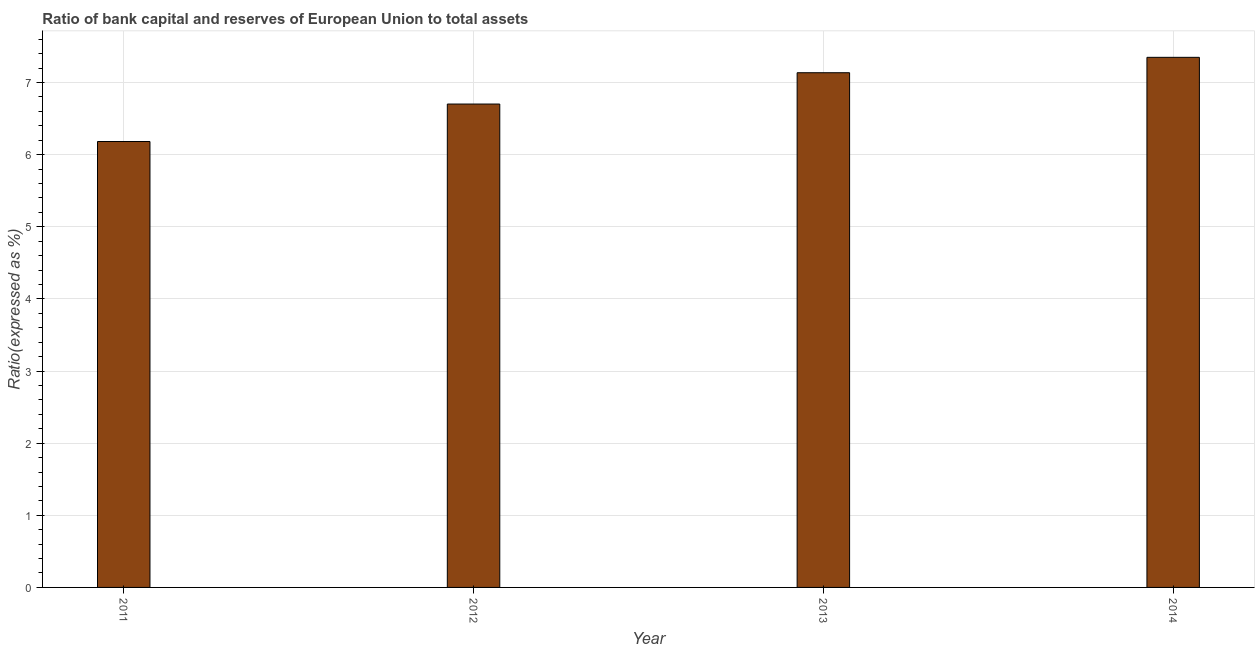Does the graph contain any zero values?
Provide a short and direct response. No. What is the title of the graph?
Your answer should be very brief. Ratio of bank capital and reserves of European Union to total assets. What is the label or title of the Y-axis?
Provide a succinct answer. Ratio(expressed as %). What is the bank capital to assets ratio in 2014?
Offer a terse response. 7.35. Across all years, what is the maximum bank capital to assets ratio?
Your answer should be compact. 7.35. Across all years, what is the minimum bank capital to assets ratio?
Ensure brevity in your answer.  6.18. In which year was the bank capital to assets ratio maximum?
Make the answer very short. 2014. What is the sum of the bank capital to assets ratio?
Make the answer very short. 27.37. What is the difference between the bank capital to assets ratio in 2012 and 2013?
Provide a short and direct response. -0.43. What is the average bank capital to assets ratio per year?
Give a very brief answer. 6.84. What is the median bank capital to assets ratio?
Give a very brief answer. 6.92. In how many years, is the bank capital to assets ratio greater than 1.8 %?
Provide a short and direct response. 4. Do a majority of the years between 2014 and 2013 (inclusive) have bank capital to assets ratio greater than 0.8 %?
Ensure brevity in your answer.  No. What is the ratio of the bank capital to assets ratio in 2011 to that in 2012?
Provide a succinct answer. 0.92. What is the difference between the highest and the second highest bank capital to assets ratio?
Make the answer very short. 0.21. What is the difference between the highest and the lowest bank capital to assets ratio?
Provide a short and direct response. 1.17. In how many years, is the bank capital to assets ratio greater than the average bank capital to assets ratio taken over all years?
Provide a short and direct response. 2. How many bars are there?
Your response must be concise. 4. How many years are there in the graph?
Your answer should be very brief. 4. What is the difference between two consecutive major ticks on the Y-axis?
Offer a terse response. 1. What is the Ratio(expressed as %) in 2011?
Offer a very short reply. 6.18. What is the Ratio(expressed as %) in 2012?
Give a very brief answer. 6.7. What is the Ratio(expressed as %) of 2013?
Your response must be concise. 7.14. What is the Ratio(expressed as %) in 2014?
Your answer should be compact. 7.35. What is the difference between the Ratio(expressed as %) in 2011 and 2012?
Offer a terse response. -0.52. What is the difference between the Ratio(expressed as %) in 2011 and 2013?
Provide a succinct answer. -0.95. What is the difference between the Ratio(expressed as %) in 2011 and 2014?
Your response must be concise. -1.17. What is the difference between the Ratio(expressed as %) in 2012 and 2013?
Your response must be concise. -0.43. What is the difference between the Ratio(expressed as %) in 2012 and 2014?
Keep it short and to the point. -0.65. What is the difference between the Ratio(expressed as %) in 2013 and 2014?
Ensure brevity in your answer.  -0.21. What is the ratio of the Ratio(expressed as %) in 2011 to that in 2012?
Offer a terse response. 0.92. What is the ratio of the Ratio(expressed as %) in 2011 to that in 2013?
Offer a terse response. 0.87. What is the ratio of the Ratio(expressed as %) in 2011 to that in 2014?
Keep it short and to the point. 0.84. What is the ratio of the Ratio(expressed as %) in 2012 to that in 2013?
Keep it short and to the point. 0.94. What is the ratio of the Ratio(expressed as %) in 2012 to that in 2014?
Ensure brevity in your answer.  0.91. What is the ratio of the Ratio(expressed as %) in 2013 to that in 2014?
Your answer should be compact. 0.97. 